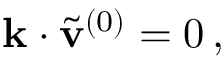<formula> <loc_0><loc_0><loc_500><loc_500>\begin{array} { r } { k \cdot \tilde { v } ^ { ( 0 ) } = 0 \, , } \end{array}</formula> 